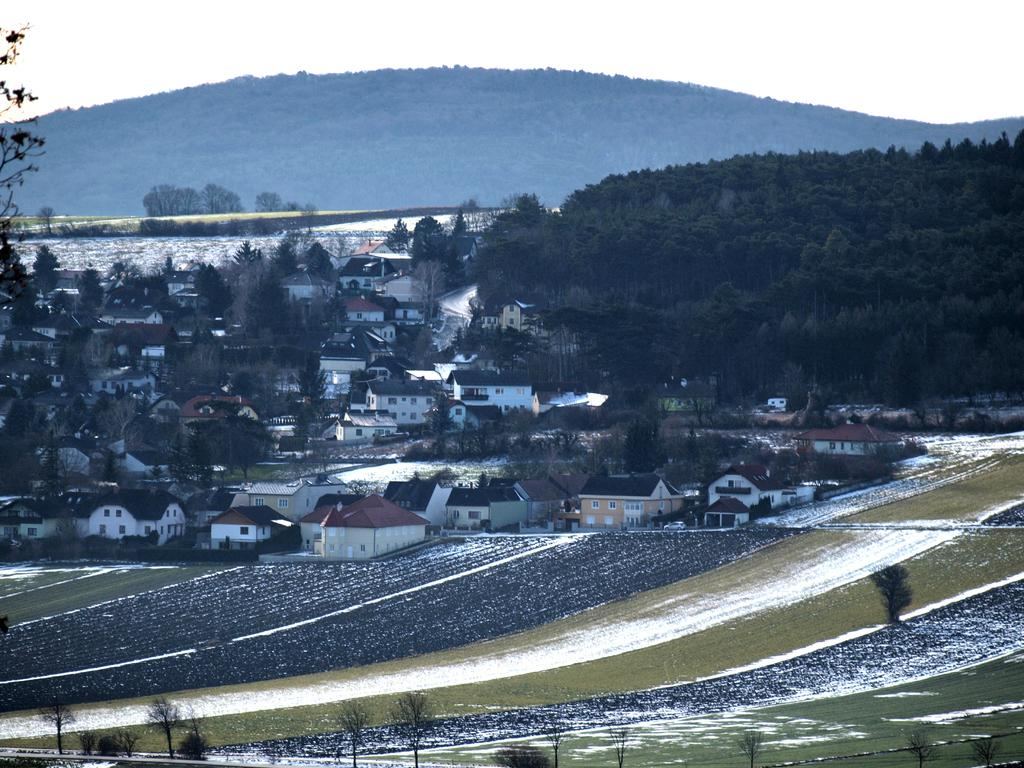What type of vegetation can be seen in the image? There are trees and grass in the image. What type of landscape is visible in the image? There are fields in the image. Are there any structures visible in the image? Yes, there are houses in the image. What can be seen in the distance in the image? There is a mountain in the background of the image. How does the muscle in the image contribute to the comfort of the person sitting on it? There is no muscle or person sitting in the image; it features trees, grass, fields, houses, and a mountain. 